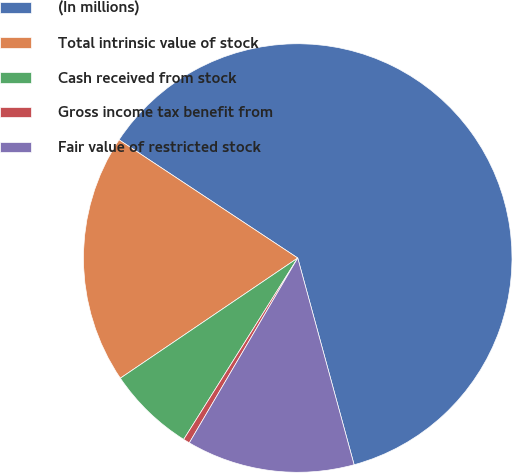<chart> <loc_0><loc_0><loc_500><loc_500><pie_chart><fcel>(In millions)<fcel>Total intrinsic value of stock<fcel>Cash received from stock<fcel>Gross income tax benefit from<fcel>Fair value of restricted stock<nl><fcel>61.46%<fcel>18.78%<fcel>6.59%<fcel>0.49%<fcel>12.68%<nl></chart> 